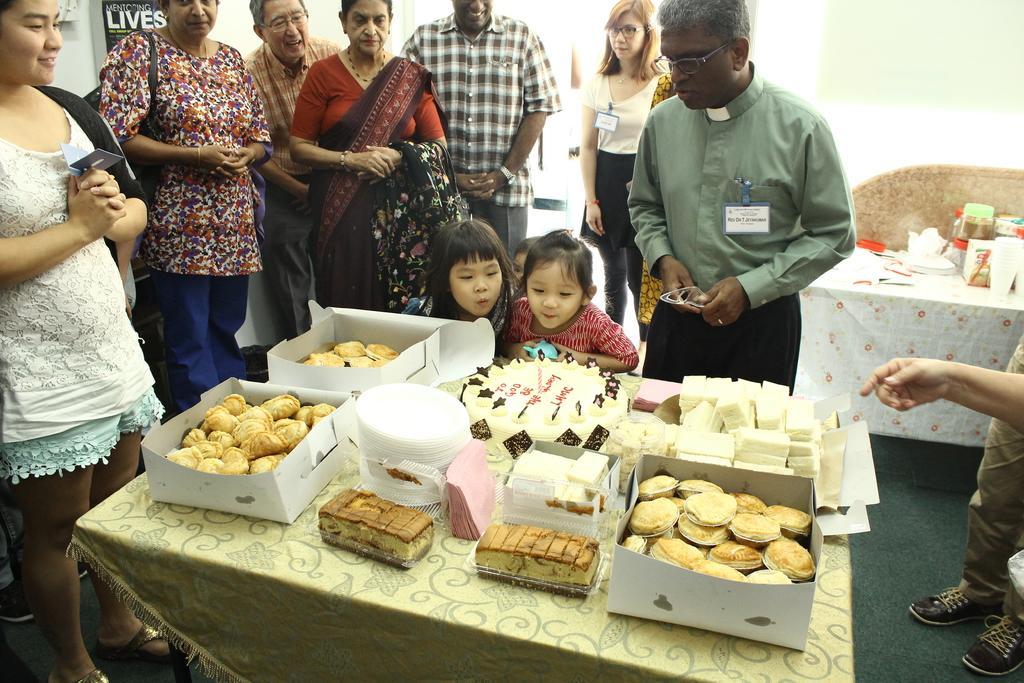Please provide a concise description of this image. In this picture we can see some people are standing and in front of the kids there is a table and on the table there are some food items in the boxes. Behind the people there is another table with some objects. 